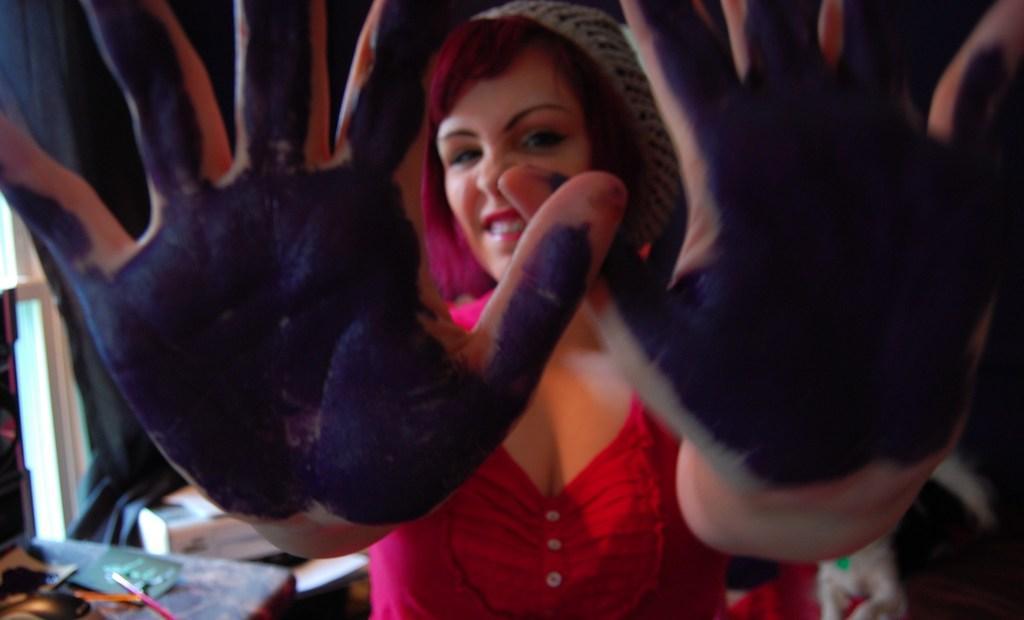Could you give a brief overview of what you see in this image? In this image we can see a woman with colors on the palm of hands. In the background the image is not clear but we can see objects and window. 